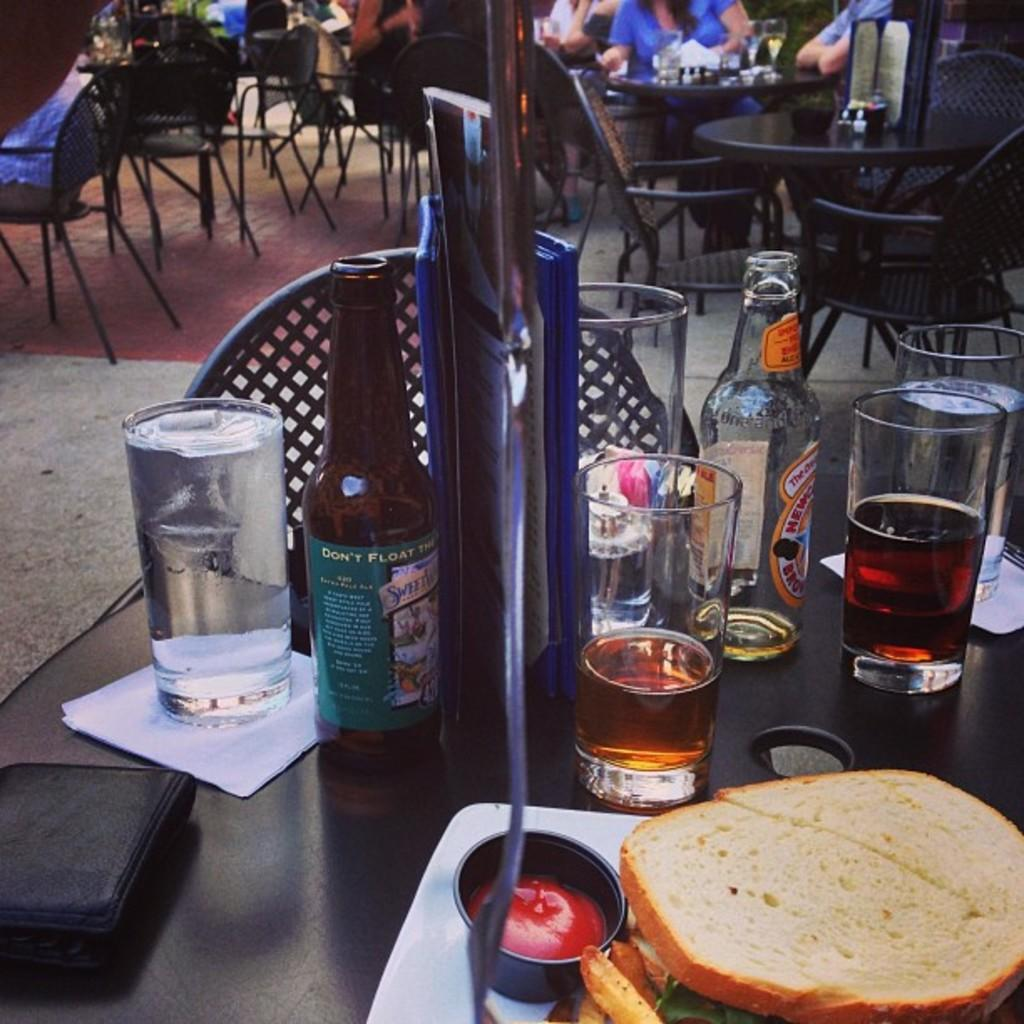What objects are on the table in the image? There are glasses and bottles on the table in the image. What type of furniture can be seen in the background? There are chairs and tables in the background. Are there any people present in the image? Yes, there are people visible in the image. What type of lipstick is the person wearing in the image? There is no lipstick or indication of lipstick visible in the image. 